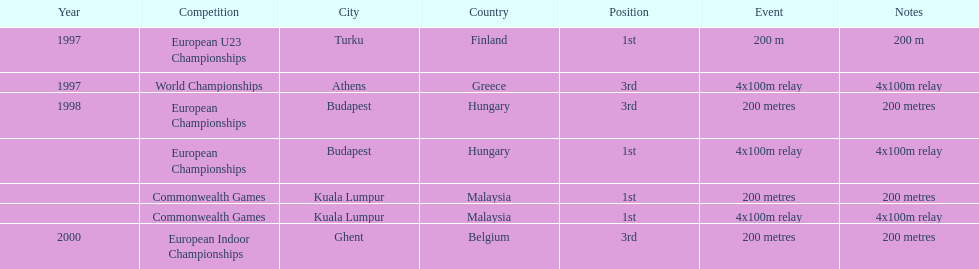List the competitions that have the same relay as world championships from athens, greece. European Championships, Commonwealth Games. 